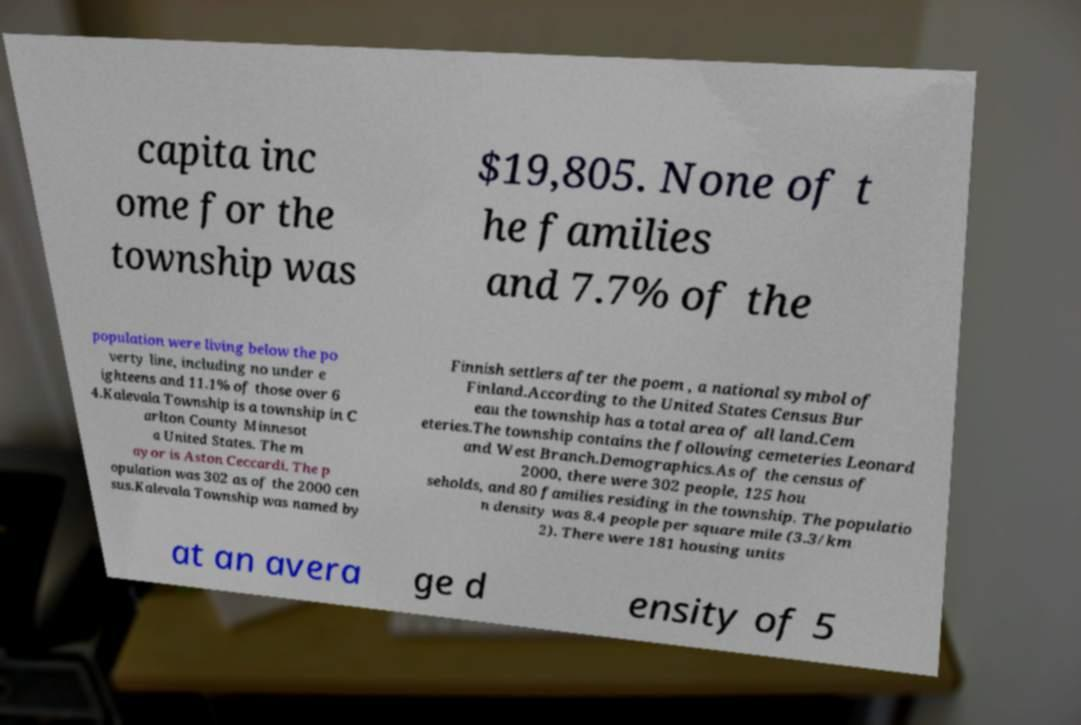Could you assist in decoding the text presented in this image and type it out clearly? capita inc ome for the township was $19,805. None of t he families and 7.7% of the population were living below the po verty line, including no under e ighteens and 11.1% of those over 6 4.Kalevala Township is a township in C arlton County Minnesot a United States. The m ayor is Aston Ceccardi. The p opulation was 302 as of the 2000 cen sus.Kalevala Township was named by Finnish settlers after the poem , a national symbol of Finland.According to the United States Census Bur eau the township has a total area of all land.Cem eteries.The township contains the following cemeteries Leonard and West Branch.Demographics.As of the census of 2000, there were 302 people, 125 hou seholds, and 80 families residing in the township. The populatio n density was 8.4 people per square mile (3.3/km 2). There were 181 housing units at an avera ge d ensity of 5 